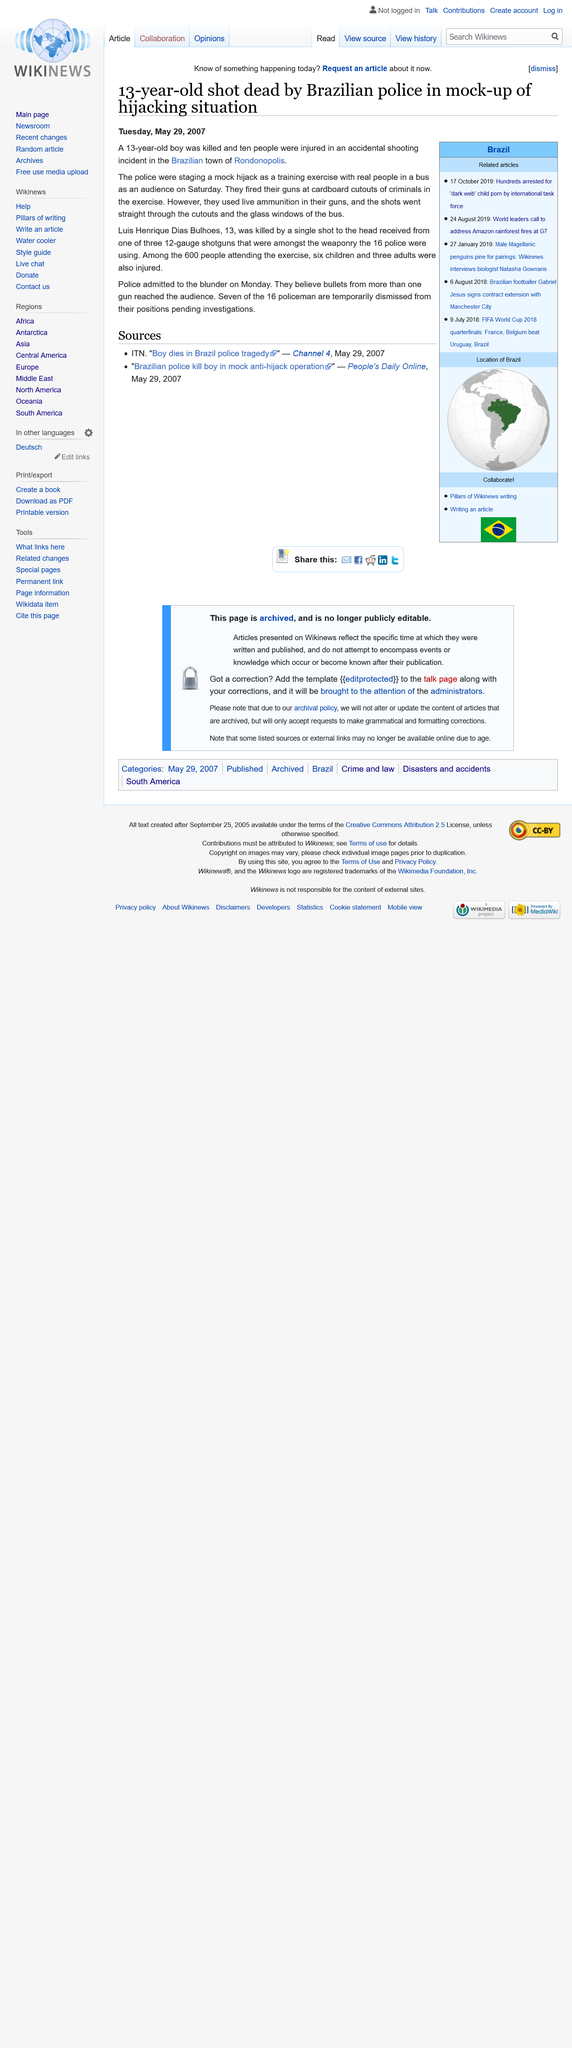Point out several critical features in this image. Sixteen police officers were involved in the incident. On August 21, 2022, a mock hijack was staged as a training exercise by the police. The police were shooting at a bus during this exercise. Luis Henrique Dias Bulhoes was killed in Rondonopolis. 